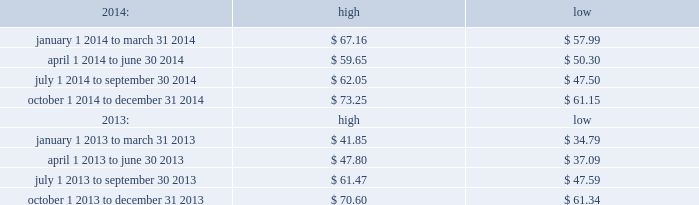Part ii item 5 .
Market for registrant 2019s common equity , related stockholder matters and issuer purchases of equity securities .
Price range our common stock trades on the nasdaq global select market under the symbol 201cmktx 201d .
The range of closing price information for our common stock , as reported by nasdaq , was as follows : on february 20 , 2015 , the last reported closing price of our common stock on the nasdaq global select market was $ 78.97 .
Holders there were 28 holders of record of our common stock as of february 20 , 2015 .
Dividend policy during 2014 , 2013 and 2012 , we paid quarterly cash dividends of $ 0.16 per share , $ 0.13 per share and $ 0.11 per share , respectively .
On december 27 , 2012 , we paid a special cash dividend of $ 1.30 per share .
In january 2015 , our board of directors approved a quarterly cash dividend of $ 0.20 per share payable on february 26 , 2015 to stockholders of record as of the close of business on february 12 , 2015 .
Any future declaration and payment of dividends will be at the sole discretion of our board of directors .
The board of directors may take into account such matters as general business conditions , our financial results , capital requirements , contractual obligations , legal and regulatory restrictions on the payment of dividends to our stockholders or by our subsidiaries to their respective parent entities , and such other factors as the board of directors may deem relevant .
Recent sales of unregistered securities securities authorized for issuance under equity compensation plans please see the section entitled 201cequity compensation plan information 201d in item 12. .

Based on the above listed holders of common stock , what was the market value of mktx common stock on february 20 , 2015? 
Computations: (78.97 * 28)
Answer: 2211.16. Part ii item 5 .
Market for registrant 2019s common equity , related stockholder matters and issuer purchases of equity securities .
Price range our common stock trades on the nasdaq global select market under the symbol 201cmktx 201d .
The range of closing price information for our common stock , as reported by nasdaq , was as follows : on february 20 , 2015 , the last reported closing price of our common stock on the nasdaq global select market was $ 78.97 .
Holders there were 28 holders of record of our common stock as of february 20 , 2015 .
Dividend policy during 2014 , 2013 and 2012 , we paid quarterly cash dividends of $ 0.16 per share , $ 0.13 per share and $ 0.11 per share , respectively .
On december 27 , 2012 , we paid a special cash dividend of $ 1.30 per share .
In january 2015 , our board of directors approved a quarterly cash dividend of $ 0.20 per share payable on february 26 , 2015 to stockholders of record as of the close of business on february 12 , 2015 .
Any future declaration and payment of dividends will be at the sole discretion of our board of directors .
The board of directors may take into account such matters as general business conditions , our financial results , capital requirements , contractual obligations , legal and regulatory restrictions on the payment of dividends to our stockholders or by our subsidiaries to their respective parent entities , and such other factors as the board of directors may deem relevant .
Recent sales of unregistered securities securities authorized for issuance under equity compensation plans please see the section entitled 201cequity compensation plan information 201d in item 12. .

By how much did the high of mktx stock increase from april 12 , 2014 to march 31 , 2014? 
Computations: ((67.16 - 59.65) / 59.65)
Answer: 0.1259. 